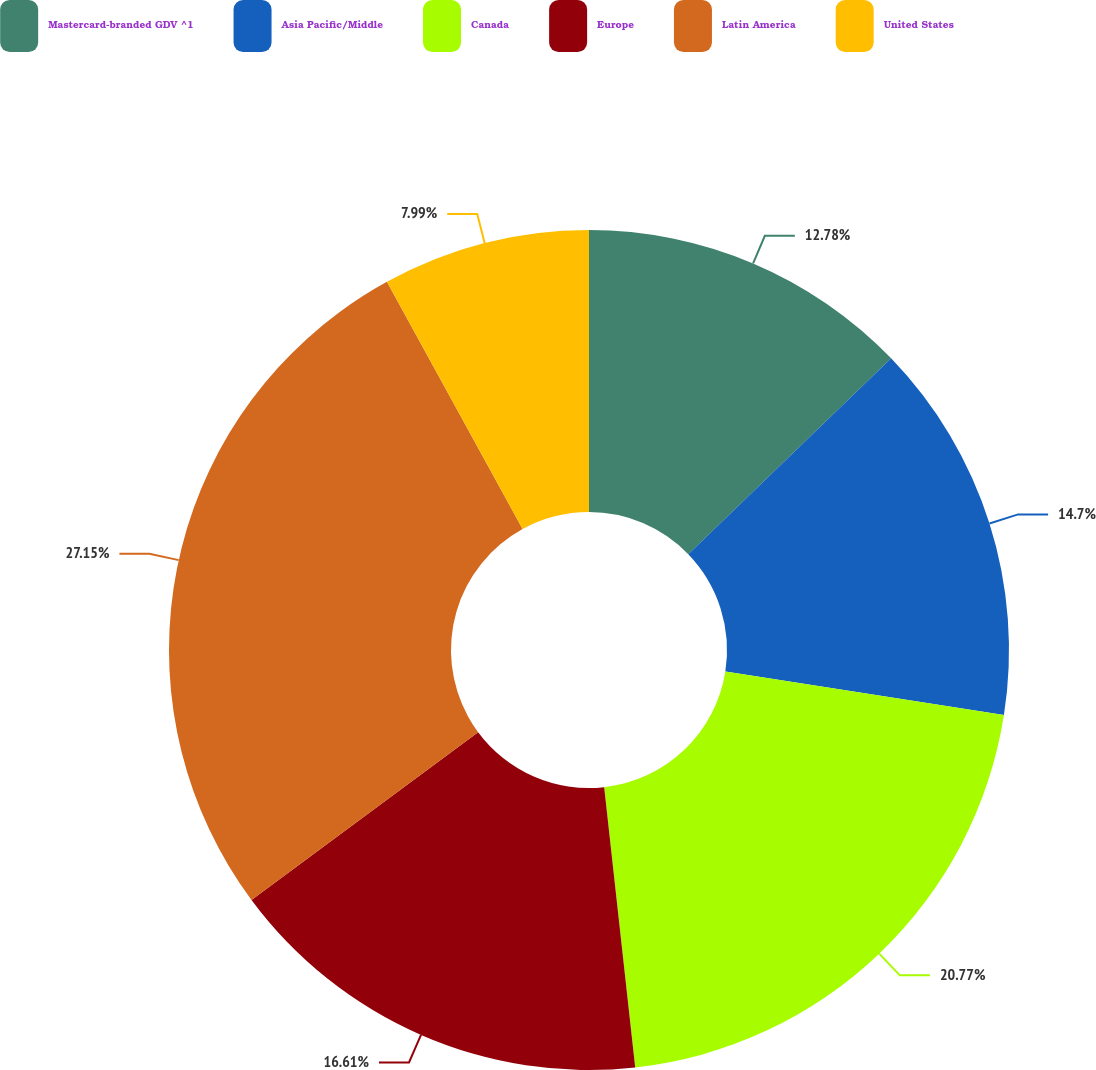<chart> <loc_0><loc_0><loc_500><loc_500><pie_chart><fcel>Mastercard-branded GDV ^1<fcel>Asia Pacific/Middle<fcel>Canada<fcel>Europe<fcel>Latin America<fcel>United States<nl><fcel>12.78%<fcel>14.7%<fcel>20.77%<fcel>16.61%<fcel>27.16%<fcel>7.99%<nl></chart> 